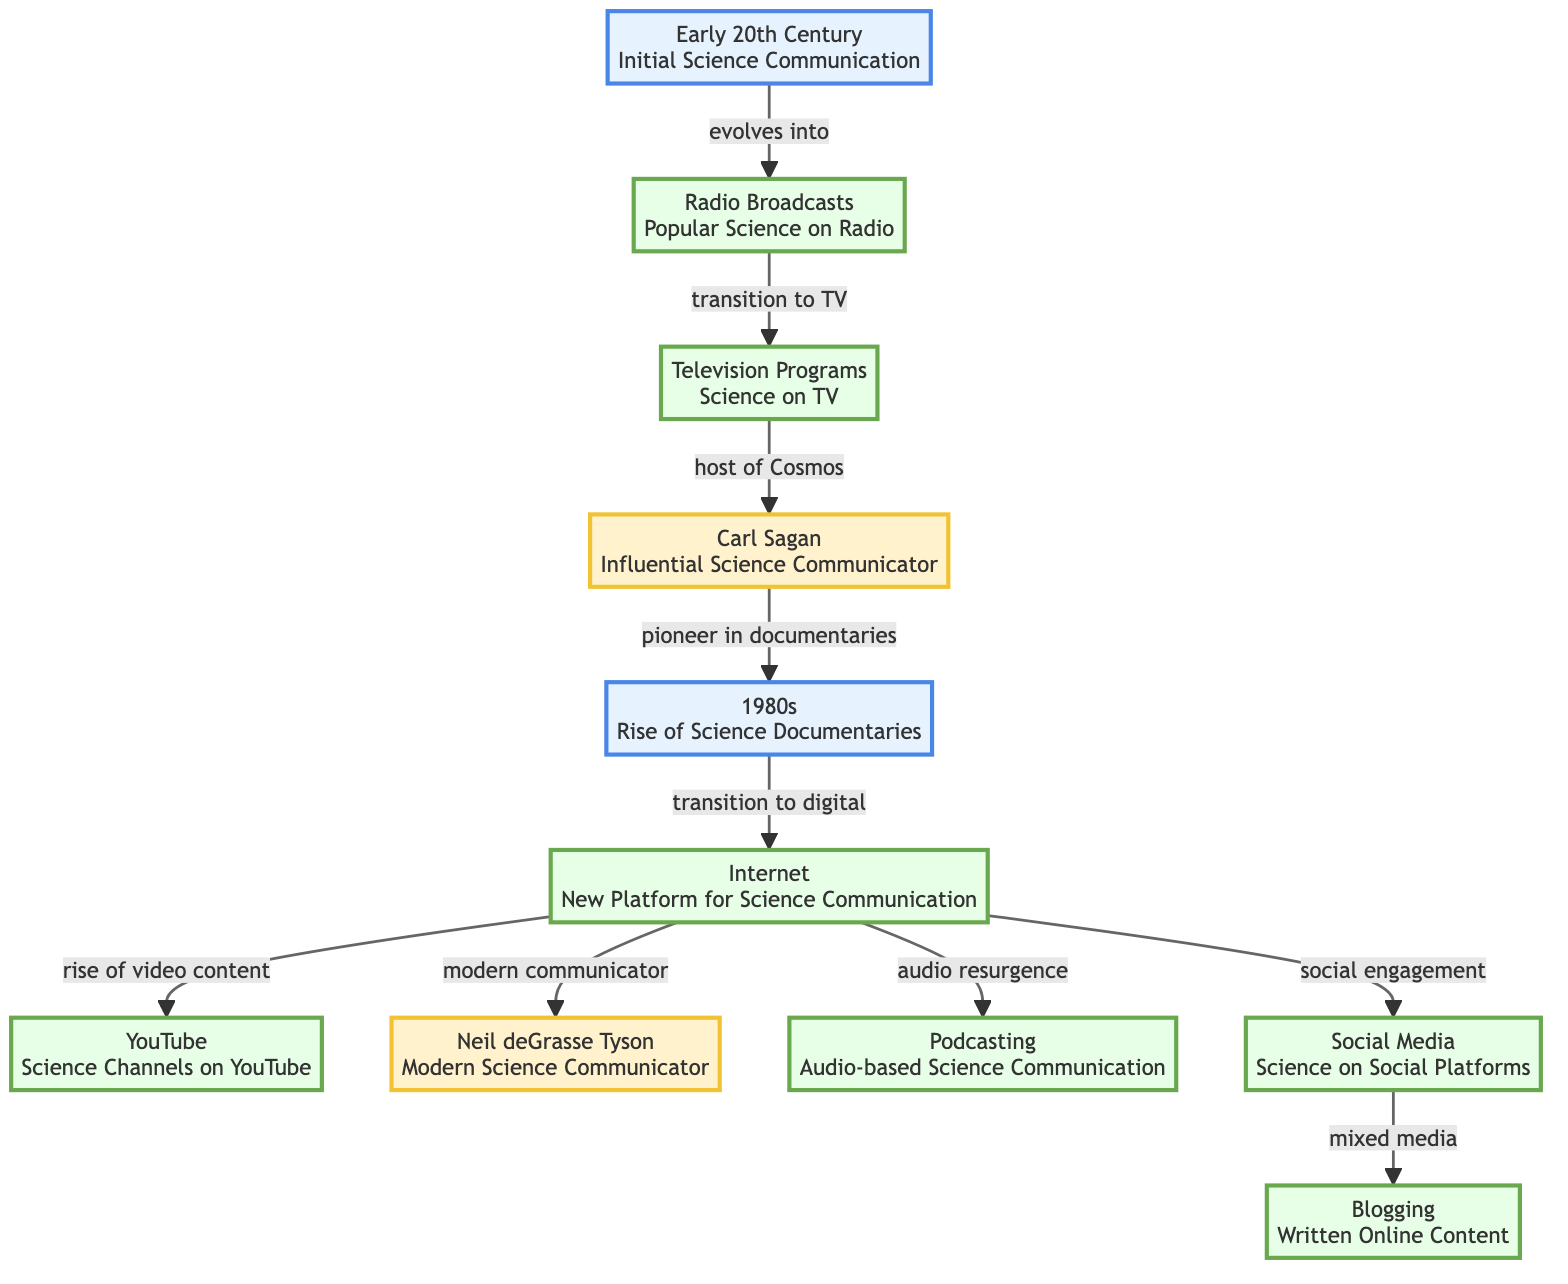What is the initial method of science communication depicted in the diagram? The diagram begins with the node labeled "Early 20th Century," which indicates the initial method of science communication.
Answer: Early 20th Century How many influential figures are present in the diagram? There are two influential figures indicated in the diagram: "Carl Sagan" and "Neil deGrasse Tyson."
Answer: 2 What method evolved from Radio Broadcasts? According to the diagram, Radio Broadcasts transitioned into Television Programs.
Answer: Television Programs What is the significant change that occurred in the 1980s according to the diagram? The diagram notes that the 1980s mark the "Rise of Science Documentaries," indicating it as a significant change during that time.
Answer: Rise of Science Documentaries Which platform indicated the rise of video content? The node labeled "YouTube" represents the rise of video content as a platform for science communication.
Answer: YouTube Identify a transition that occurred between the Internet and Social Media. The diagram shows that the Internet led to the rise of Social Media, indicating a transition from one to the other.
Answer: rise of Social Media What connects Social Media to Blogging in the diagram? The connection indicated in the diagram shows that Social Media leads to "mixed media," which then connects to Blogging.
Answer: mixed media What is the relationship between Carl Sagan and the 1980s as shown in the diagram? Carl Sagan is identified as a "pioneer in documentaries," which links to the 1980s, suggesting his influence on that era.
Answer: pioneer in documentaries What type of communication does Podcasting represent in the evolution of science communication? The diagram illustrates Podcasting as a form of "Audio-based Science Communication," indicating its specific type.
Answer: Audio-based Science Communication What is the role of the Internet in modern science communication? The Internet is depicted as the "New Platform for Science Communication," highlighting its central role in modern methods.
Answer: New Platform for Science Communication 